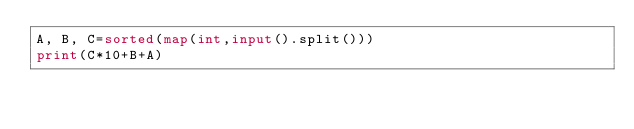Convert code to text. <code><loc_0><loc_0><loc_500><loc_500><_Python_>A, B, C=sorted(map(int,input().split()))
print(C*10+B+A)</code> 